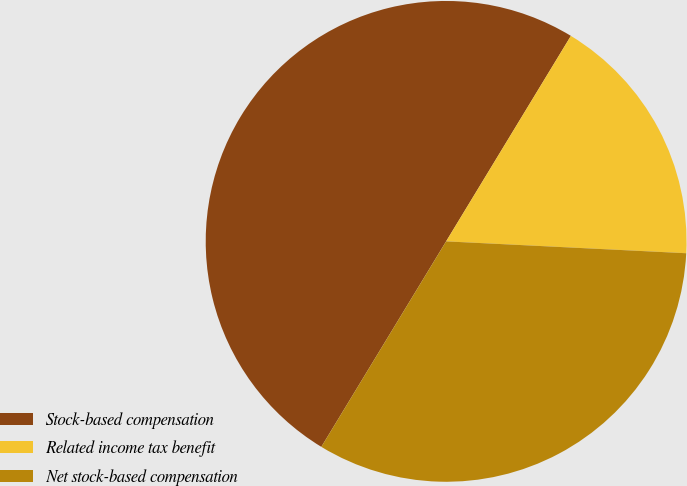<chart> <loc_0><loc_0><loc_500><loc_500><pie_chart><fcel>Stock-based compensation<fcel>Related income tax benefit<fcel>Net stock-based compensation<nl><fcel>50.0%<fcel>17.1%<fcel>32.9%<nl></chart> 